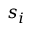<formula> <loc_0><loc_0><loc_500><loc_500>s _ { i }</formula> 